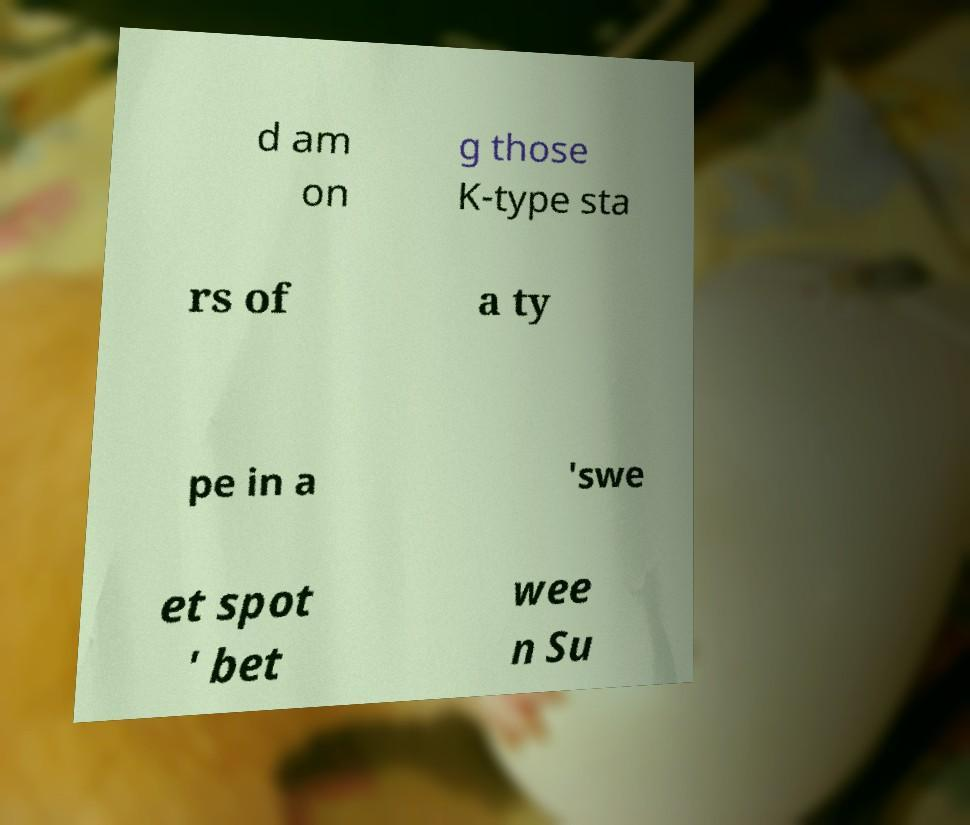Can you accurately transcribe the text from the provided image for me? d am on g those K-type sta rs of a ty pe in a 'swe et spot ' bet wee n Su 